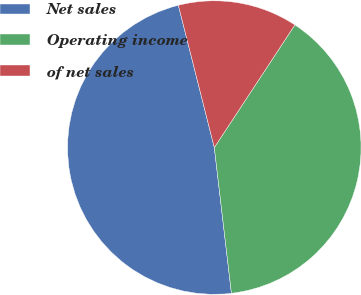Convert chart to OTSL. <chart><loc_0><loc_0><loc_500><loc_500><pie_chart><fcel>Net sales<fcel>Operating income<fcel>of net sales<nl><fcel>47.92%<fcel>38.89%<fcel>13.19%<nl></chart> 